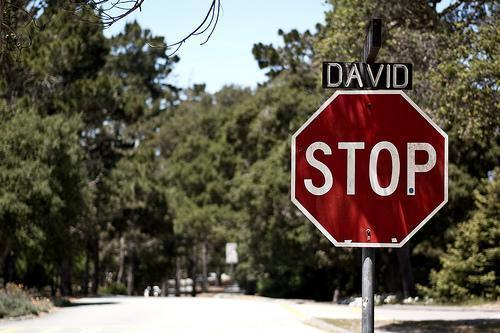How many signs are there?
Give a very brief answer. 2. 